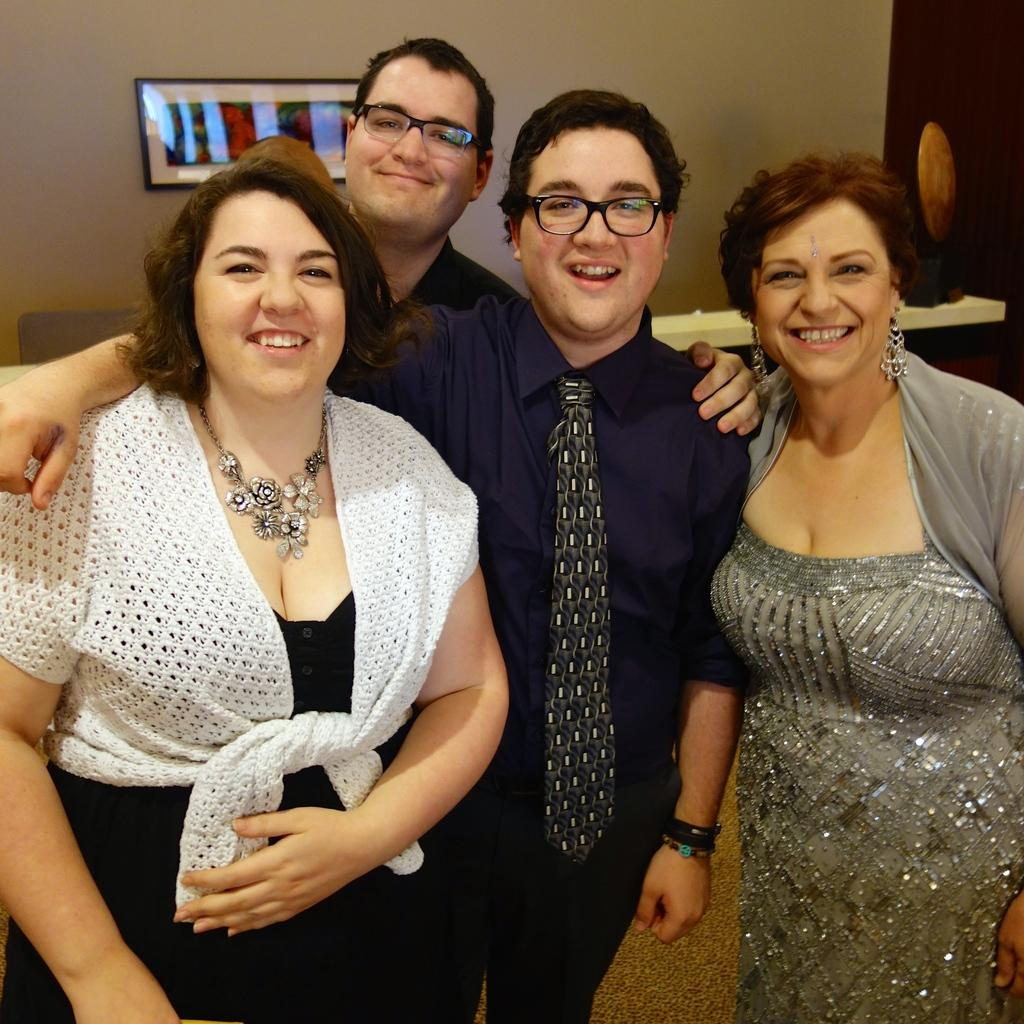What are the people in the image doing? The persons standing in the center of the image are smiling. Can you describe the mood of the people in the image? The people are smiling, which suggests a positive or happy mood. What is visible on the wall in the background of the image? There is a frame on the wall in the background of the image. What is the color of the wall in the image? The wall is white in color. What type of history lesson is the fireman giving in the image? There is no fireman or history lesson present in the image. How does the temper of the persons in the image affect their expressions? The provided facts do not mention the temper of the persons in the image, so we cannot determine how it affects their expressions. 